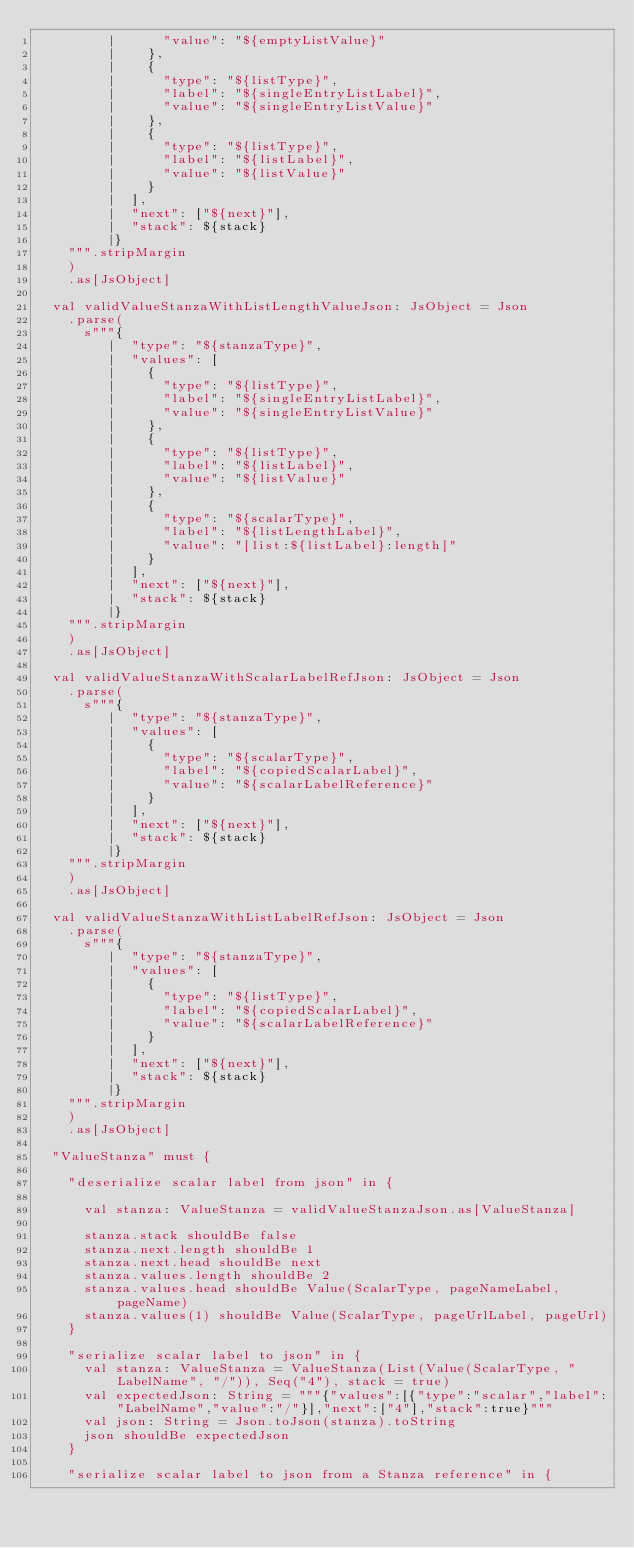<code> <loc_0><loc_0><loc_500><loc_500><_Scala_>         |      "value": "${emptyListValue}"
         |    },
         |    {
         |      "type": "${listType}",
         |      "label": "${singleEntryListLabel}",
         |      "value": "${singleEntryListValue}"
         |    },
         |    {
         |      "type": "${listType}",
         |      "label": "${listLabel}",
         |      "value": "${listValue}"
         |    }
         |  ],
         |  "next": ["${next}"],
         |  "stack": ${stack}
         |}
    """.stripMargin
    )
    .as[JsObject]

  val validValueStanzaWithListLengthValueJson: JsObject = Json
    .parse(
      s"""{
         |  "type": "${stanzaType}",
         |  "values": [
         |    {
         |      "type": "${listType}",
         |      "label": "${singleEntryListLabel}",
         |      "value": "${singleEntryListValue}"
         |    },
         |    {
         |      "type": "${listType}",
         |      "label": "${listLabel}",
         |      "value": "${listValue}"
         |    },
         |    {
         |      "type": "${scalarType}",
         |      "label": "${listLengthLabel}",
         |      "value": "[list:${listLabel}:length]"
         |    }
         |  ],
         |  "next": ["${next}"],
         |  "stack": ${stack}
         |}
    """.stripMargin
    )
    .as[JsObject]

  val validValueStanzaWithScalarLabelRefJson: JsObject = Json
    .parse(
      s"""{
         |  "type": "${stanzaType}",
         |  "values": [
         |    {
         |      "type": "${scalarType}",
         |      "label": "${copiedScalarLabel}",
         |      "value": "${scalarLabelReference}"
         |    }
         |  ],
         |  "next": ["${next}"],
         |  "stack": ${stack}
         |}
    """.stripMargin
    )
    .as[JsObject]

  val validValueStanzaWithListLabelRefJson: JsObject = Json
    .parse(
      s"""{
         |  "type": "${stanzaType}",
         |  "values": [
         |    {
         |      "type": "${listType}",
         |      "label": "${copiedScalarLabel}",
         |      "value": "${scalarLabelReference}"
         |    }
         |  ],
         |  "next": ["${next}"],
         |  "stack": ${stack}
         |}
    """.stripMargin
    )
    .as[JsObject]

  "ValueStanza" must {

    "deserialize scalar label from json" in {

      val stanza: ValueStanza = validValueStanzaJson.as[ValueStanza]

      stanza.stack shouldBe false
      stanza.next.length shouldBe 1
      stanza.next.head shouldBe next
      stanza.values.length shouldBe 2
      stanza.values.head shouldBe Value(ScalarType, pageNameLabel, pageName)
      stanza.values(1) shouldBe Value(ScalarType, pageUrlLabel, pageUrl)
    }

    "serialize scalar label to json" in {
      val stanza: ValueStanza = ValueStanza(List(Value(ScalarType, "LabelName", "/")), Seq("4"), stack = true)
      val expectedJson: String = """{"values":[{"type":"scalar","label":"LabelName","value":"/"}],"next":["4"],"stack":true}"""
      val json: String = Json.toJson(stanza).toString
      json shouldBe expectedJson
    }

    "serialize scalar label to json from a Stanza reference" in {</code> 